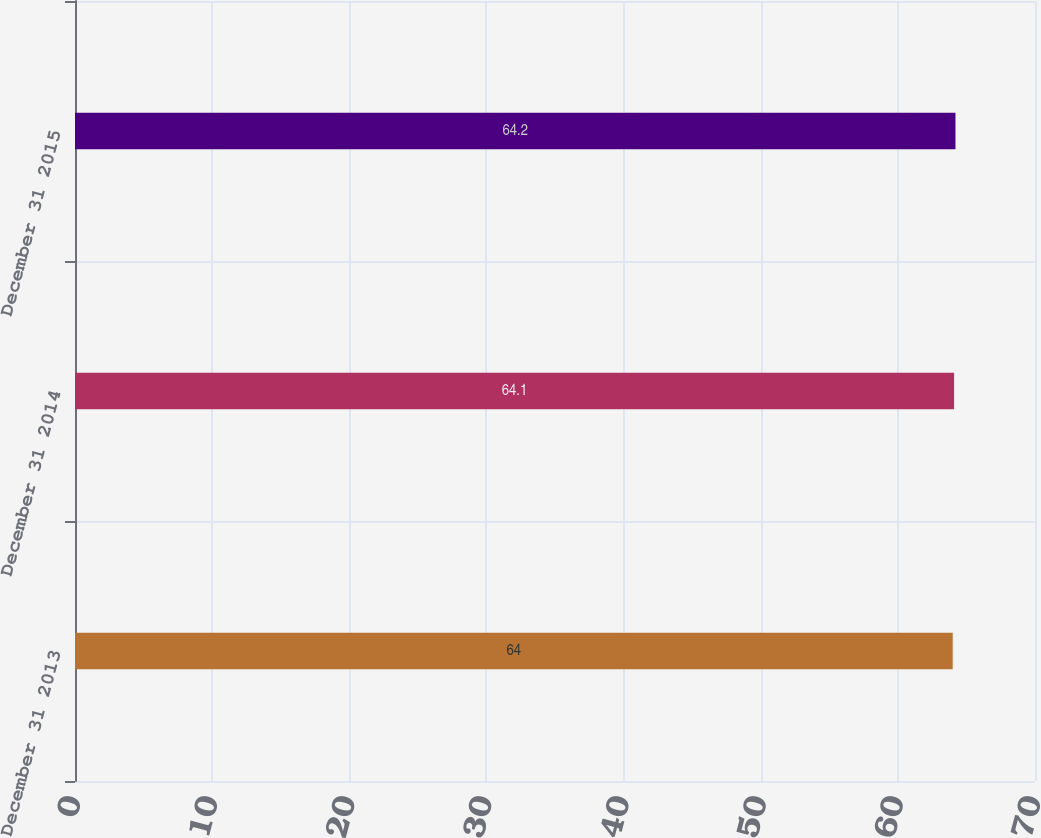<chart> <loc_0><loc_0><loc_500><loc_500><bar_chart><fcel>December 31 2013<fcel>December 31 2014<fcel>December 31 2015<nl><fcel>64<fcel>64.1<fcel>64.2<nl></chart> 